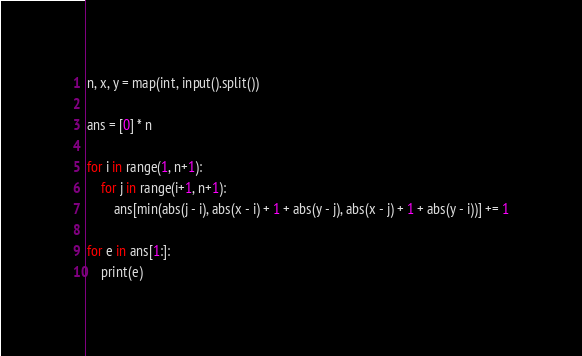Convert code to text. <code><loc_0><loc_0><loc_500><loc_500><_Python_>n, x, y = map(int, input().split())

ans = [0] * n

for i in range(1, n+1):
    for j in range(i+1, n+1):
        ans[min(abs(j - i), abs(x - i) + 1 + abs(y - j), abs(x - j) + 1 + abs(y - i))] += 1

for e in ans[1:]:
    print(e)
</code> 